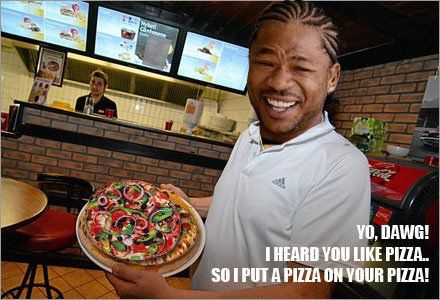Please transcribe the text information in this image. YO DAWG LIKE PIZZA. PIZZA YOUR SO I PUT ON PIZZA A YOU HEARD I COLA 